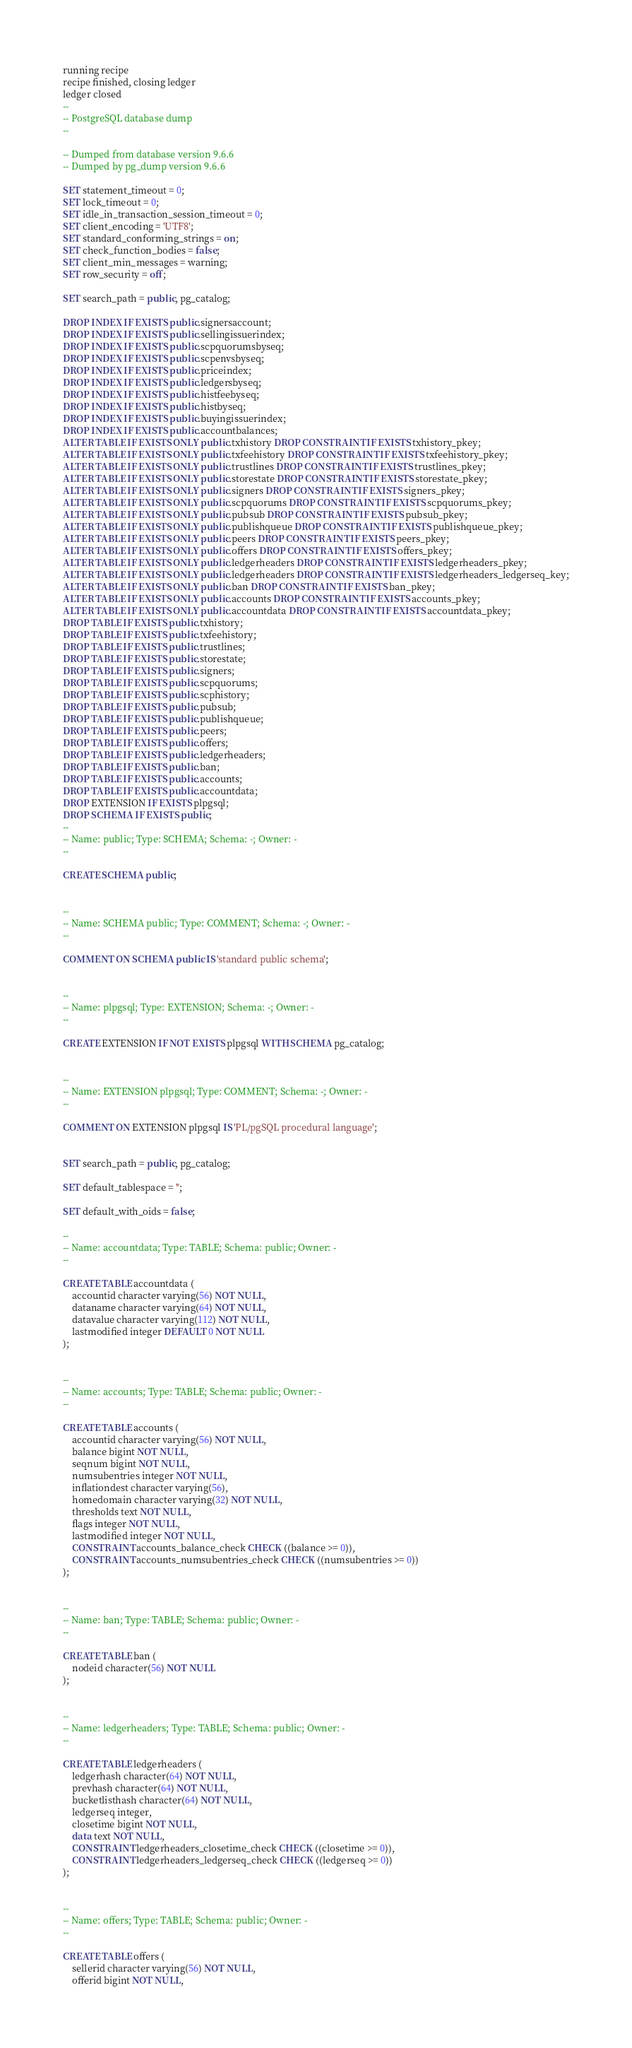<code> <loc_0><loc_0><loc_500><loc_500><_SQL_>running recipe
recipe finished, closing ledger
ledger closed
--
-- PostgreSQL database dump
--

-- Dumped from database version 9.6.6
-- Dumped by pg_dump version 9.6.6

SET statement_timeout = 0;
SET lock_timeout = 0;
SET idle_in_transaction_session_timeout = 0;
SET client_encoding = 'UTF8';
SET standard_conforming_strings = on;
SET check_function_bodies = false;
SET client_min_messages = warning;
SET row_security = off;

SET search_path = public, pg_catalog;

DROP INDEX IF EXISTS public.signersaccount;
DROP INDEX IF EXISTS public.sellingissuerindex;
DROP INDEX IF EXISTS public.scpquorumsbyseq;
DROP INDEX IF EXISTS public.scpenvsbyseq;
DROP INDEX IF EXISTS public.priceindex;
DROP INDEX IF EXISTS public.ledgersbyseq;
DROP INDEX IF EXISTS public.histfeebyseq;
DROP INDEX IF EXISTS public.histbyseq;
DROP INDEX IF EXISTS public.buyingissuerindex;
DROP INDEX IF EXISTS public.accountbalances;
ALTER TABLE IF EXISTS ONLY public.txhistory DROP CONSTRAINT IF EXISTS txhistory_pkey;
ALTER TABLE IF EXISTS ONLY public.txfeehistory DROP CONSTRAINT IF EXISTS txfeehistory_pkey;
ALTER TABLE IF EXISTS ONLY public.trustlines DROP CONSTRAINT IF EXISTS trustlines_pkey;
ALTER TABLE IF EXISTS ONLY public.storestate DROP CONSTRAINT IF EXISTS storestate_pkey;
ALTER TABLE IF EXISTS ONLY public.signers DROP CONSTRAINT IF EXISTS signers_pkey;
ALTER TABLE IF EXISTS ONLY public.scpquorums DROP CONSTRAINT IF EXISTS scpquorums_pkey;
ALTER TABLE IF EXISTS ONLY public.pubsub DROP CONSTRAINT IF EXISTS pubsub_pkey;
ALTER TABLE IF EXISTS ONLY public.publishqueue DROP CONSTRAINT IF EXISTS publishqueue_pkey;
ALTER TABLE IF EXISTS ONLY public.peers DROP CONSTRAINT IF EXISTS peers_pkey;
ALTER TABLE IF EXISTS ONLY public.offers DROP CONSTRAINT IF EXISTS offers_pkey;
ALTER TABLE IF EXISTS ONLY public.ledgerheaders DROP CONSTRAINT IF EXISTS ledgerheaders_pkey;
ALTER TABLE IF EXISTS ONLY public.ledgerheaders DROP CONSTRAINT IF EXISTS ledgerheaders_ledgerseq_key;
ALTER TABLE IF EXISTS ONLY public.ban DROP CONSTRAINT IF EXISTS ban_pkey;
ALTER TABLE IF EXISTS ONLY public.accounts DROP CONSTRAINT IF EXISTS accounts_pkey;
ALTER TABLE IF EXISTS ONLY public.accountdata DROP CONSTRAINT IF EXISTS accountdata_pkey;
DROP TABLE IF EXISTS public.txhistory;
DROP TABLE IF EXISTS public.txfeehistory;
DROP TABLE IF EXISTS public.trustlines;
DROP TABLE IF EXISTS public.storestate;
DROP TABLE IF EXISTS public.signers;
DROP TABLE IF EXISTS public.scpquorums;
DROP TABLE IF EXISTS public.scphistory;
DROP TABLE IF EXISTS public.pubsub;
DROP TABLE IF EXISTS public.publishqueue;
DROP TABLE IF EXISTS public.peers;
DROP TABLE IF EXISTS public.offers;
DROP TABLE IF EXISTS public.ledgerheaders;
DROP TABLE IF EXISTS public.ban;
DROP TABLE IF EXISTS public.accounts;
DROP TABLE IF EXISTS public.accountdata;
DROP EXTENSION IF EXISTS plpgsql;
DROP SCHEMA IF EXISTS public;
--
-- Name: public; Type: SCHEMA; Schema: -; Owner: -
--

CREATE SCHEMA public;


--
-- Name: SCHEMA public; Type: COMMENT; Schema: -; Owner: -
--

COMMENT ON SCHEMA public IS 'standard public schema';


--
-- Name: plpgsql; Type: EXTENSION; Schema: -; Owner: -
--

CREATE EXTENSION IF NOT EXISTS plpgsql WITH SCHEMA pg_catalog;


--
-- Name: EXTENSION plpgsql; Type: COMMENT; Schema: -; Owner: -
--

COMMENT ON EXTENSION plpgsql IS 'PL/pgSQL procedural language';


SET search_path = public, pg_catalog;

SET default_tablespace = '';

SET default_with_oids = false;

--
-- Name: accountdata; Type: TABLE; Schema: public; Owner: -
--

CREATE TABLE accountdata (
    accountid character varying(56) NOT NULL,
    dataname character varying(64) NOT NULL,
    datavalue character varying(112) NOT NULL,
    lastmodified integer DEFAULT 0 NOT NULL
);


--
-- Name: accounts; Type: TABLE; Schema: public; Owner: -
--

CREATE TABLE accounts (
    accountid character varying(56) NOT NULL,
    balance bigint NOT NULL,
    seqnum bigint NOT NULL,
    numsubentries integer NOT NULL,
    inflationdest character varying(56),
    homedomain character varying(32) NOT NULL,
    thresholds text NOT NULL,
    flags integer NOT NULL,
    lastmodified integer NOT NULL,
    CONSTRAINT accounts_balance_check CHECK ((balance >= 0)),
    CONSTRAINT accounts_numsubentries_check CHECK ((numsubentries >= 0))
);


--
-- Name: ban; Type: TABLE; Schema: public; Owner: -
--

CREATE TABLE ban (
    nodeid character(56) NOT NULL
);


--
-- Name: ledgerheaders; Type: TABLE; Schema: public; Owner: -
--

CREATE TABLE ledgerheaders (
    ledgerhash character(64) NOT NULL,
    prevhash character(64) NOT NULL,
    bucketlisthash character(64) NOT NULL,
    ledgerseq integer,
    closetime bigint NOT NULL,
    data text NOT NULL,
    CONSTRAINT ledgerheaders_closetime_check CHECK ((closetime >= 0)),
    CONSTRAINT ledgerheaders_ledgerseq_check CHECK ((ledgerseq >= 0))
);


--
-- Name: offers; Type: TABLE; Schema: public; Owner: -
--

CREATE TABLE offers (
    sellerid character varying(56) NOT NULL,
    offerid bigint NOT NULL,</code> 